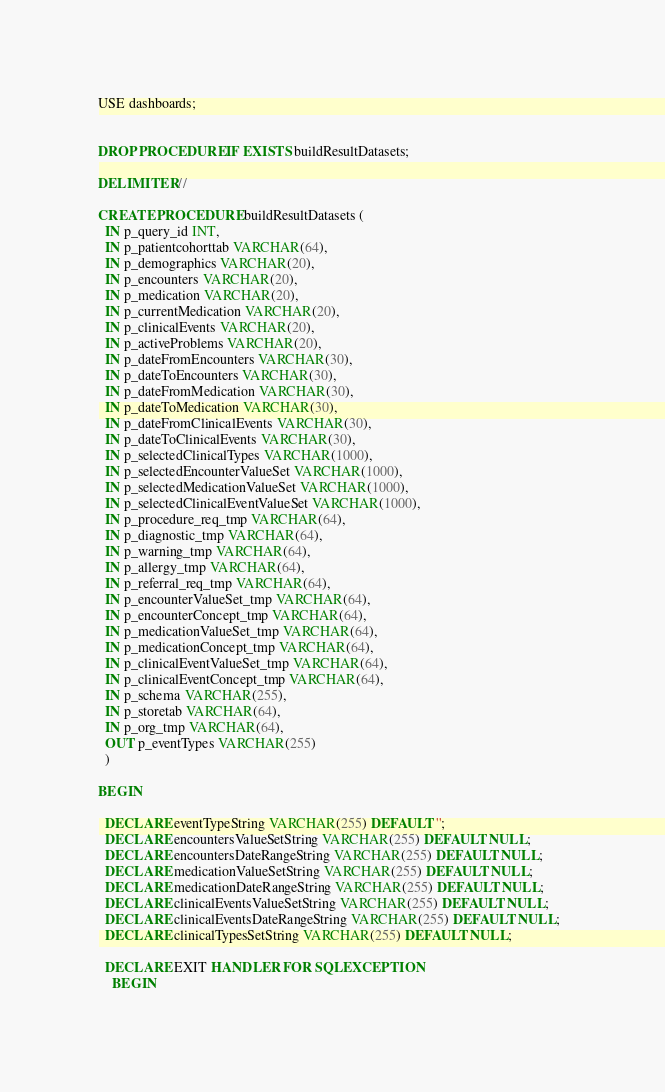Convert code to text. <code><loc_0><loc_0><loc_500><loc_500><_SQL_>USE dashboards;


DROP PROCEDURE IF EXISTS buildResultDatasets;

DELIMITER //

CREATE PROCEDURE buildResultDatasets (
  IN p_query_id INT,
  IN p_patientcohorttab VARCHAR(64),
  IN p_demographics VARCHAR(20),
  IN p_encounters VARCHAR(20),
  IN p_medication VARCHAR(20),
  IN p_currentMedication VARCHAR(20),
  IN p_clinicalEvents VARCHAR(20),
  IN p_activeProblems VARCHAR(20),
  IN p_dateFromEncounters VARCHAR(30),
  IN p_dateToEncounters VARCHAR(30),
  IN p_dateFromMedication VARCHAR(30),
  IN p_dateToMedication VARCHAR(30),
  IN p_dateFromClinicalEvents VARCHAR(30),
  IN p_dateToClinicalEvents VARCHAR(30),
  IN p_selectedClinicalTypes VARCHAR(1000),
  IN p_selectedEncounterValueSet VARCHAR(1000),
  IN p_selectedMedicationValueSet VARCHAR(1000),
  IN p_selectedClinicalEventValueSet VARCHAR(1000),
  IN p_procedure_req_tmp VARCHAR(64),
  IN p_diagnostic_tmp VARCHAR(64),
  IN p_warning_tmp VARCHAR(64),
  IN p_allergy_tmp VARCHAR(64),
  IN p_referral_req_tmp VARCHAR(64),
  IN p_encounterValueSet_tmp VARCHAR(64),
  IN p_encounterConcept_tmp VARCHAR(64),
  IN p_medicationValueSet_tmp VARCHAR(64),
  IN p_medicationConcept_tmp VARCHAR(64),
  IN p_clinicalEventValueSet_tmp VARCHAR(64),
  IN p_clinicalEventConcept_tmp VARCHAR(64),
  IN p_schema VARCHAR(255),
  IN p_storetab VARCHAR(64),
  IN p_org_tmp VARCHAR(64), 
  OUT p_eventTypes VARCHAR(255)
  )

BEGIN
  
  DECLARE eventTypeString VARCHAR(255) DEFAULT '';
  DECLARE encountersValueSetString VARCHAR(255) DEFAULT NULL; 
  DECLARE encountersDateRangeString VARCHAR(255) DEFAULT NULL; 
  DECLARE medicationValueSetString VARCHAR(255) DEFAULT NULL; 
  DECLARE medicationDateRangeString VARCHAR(255) DEFAULT NULL;  
  DECLARE clinicalEventsValueSetString VARCHAR(255) DEFAULT NULL; 
  DECLARE clinicalEventsDateRangeString VARCHAR(255) DEFAULT NULL;  
  DECLARE clinicalTypesSetString VARCHAR(255) DEFAULT NULL; 

  DECLARE EXIT HANDLER FOR SQLEXCEPTION
    BEGIN</code> 